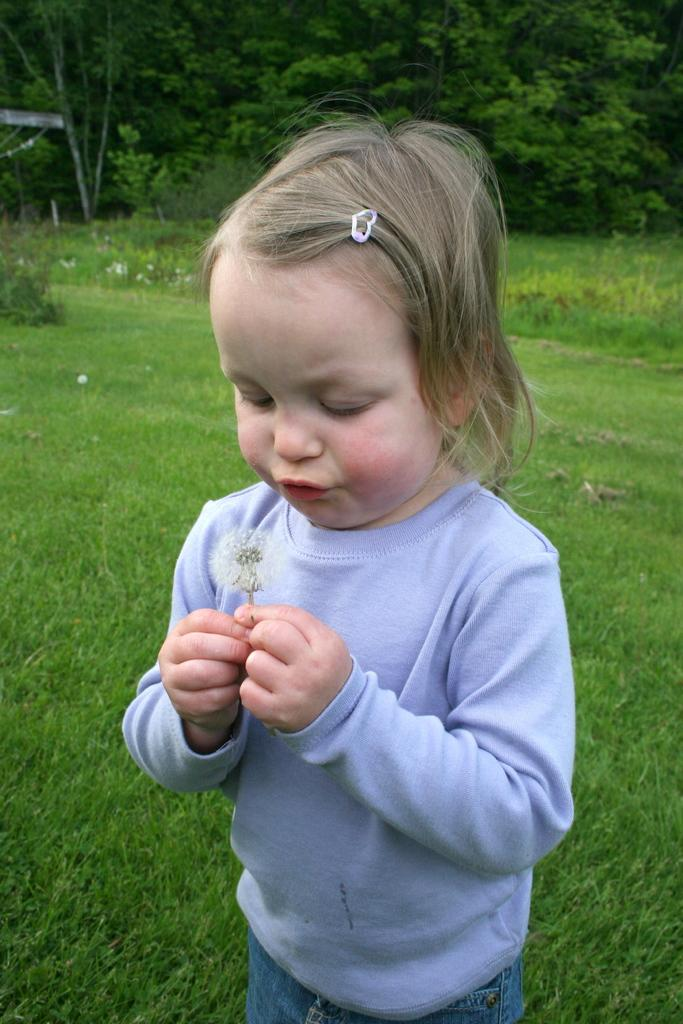Who is the main subject in the image? There is a girl in the center of the image. What can be seen in the background of the image? There are trees in the background of the image. What type of ground is visible at the bottom of the image? There is grass at the bottom of the image. What type of vegetable is the laborer carrying in the image? There is no laborer or vegetable present in the image. 